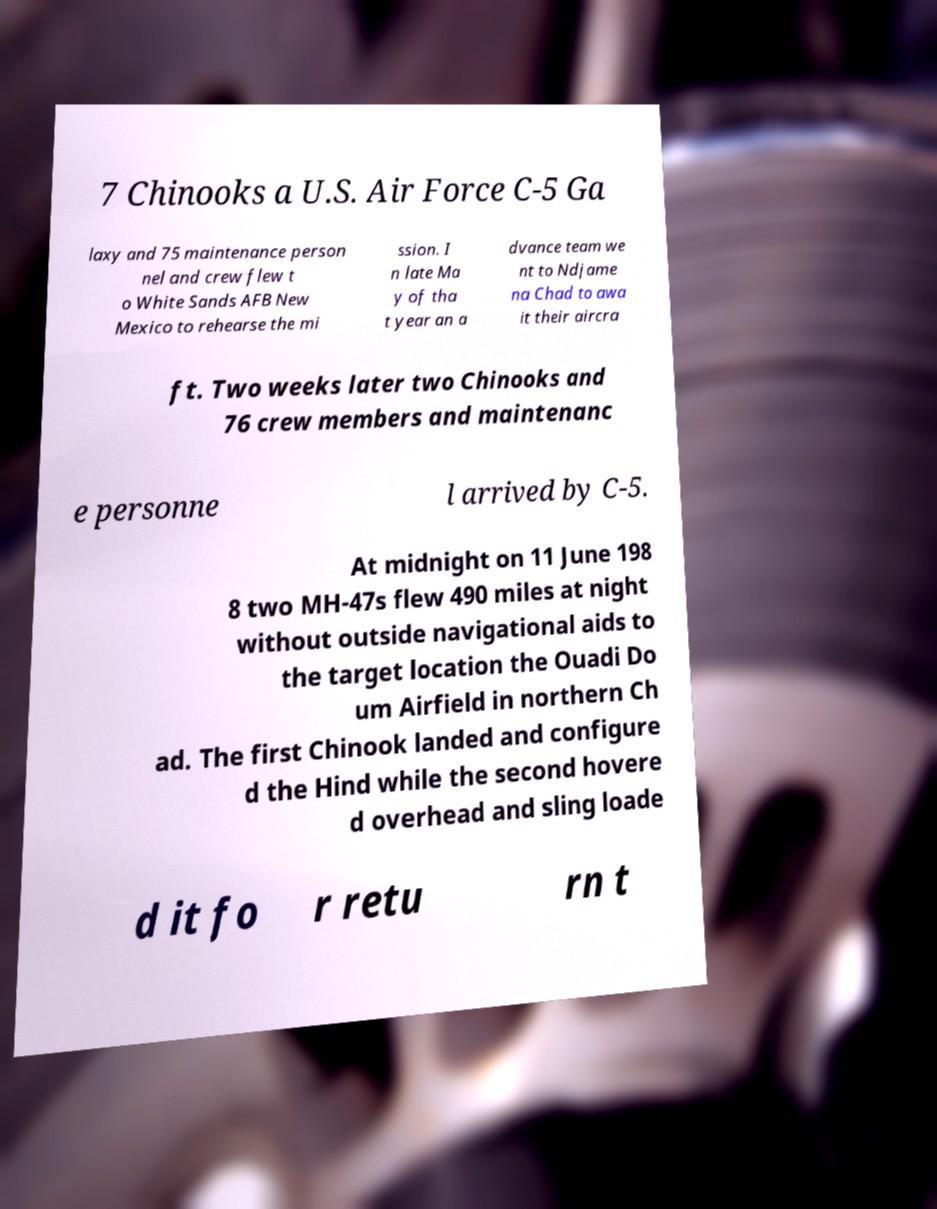Please identify and transcribe the text found in this image. 7 Chinooks a U.S. Air Force C-5 Ga laxy and 75 maintenance person nel and crew flew t o White Sands AFB New Mexico to rehearse the mi ssion. I n late Ma y of tha t year an a dvance team we nt to Ndjame na Chad to awa it their aircra ft. Two weeks later two Chinooks and 76 crew members and maintenanc e personne l arrived by C-5. At midnight on 11 June 198 8 two MH-47s flew 490 miles at night without outside navigational aids to the target location the Ouadi Do um Airfield in northern Ch ad. The first Chinook landed and configure d the Hind while the second hovere d overhead and sling loade d it fo r retu rn t 